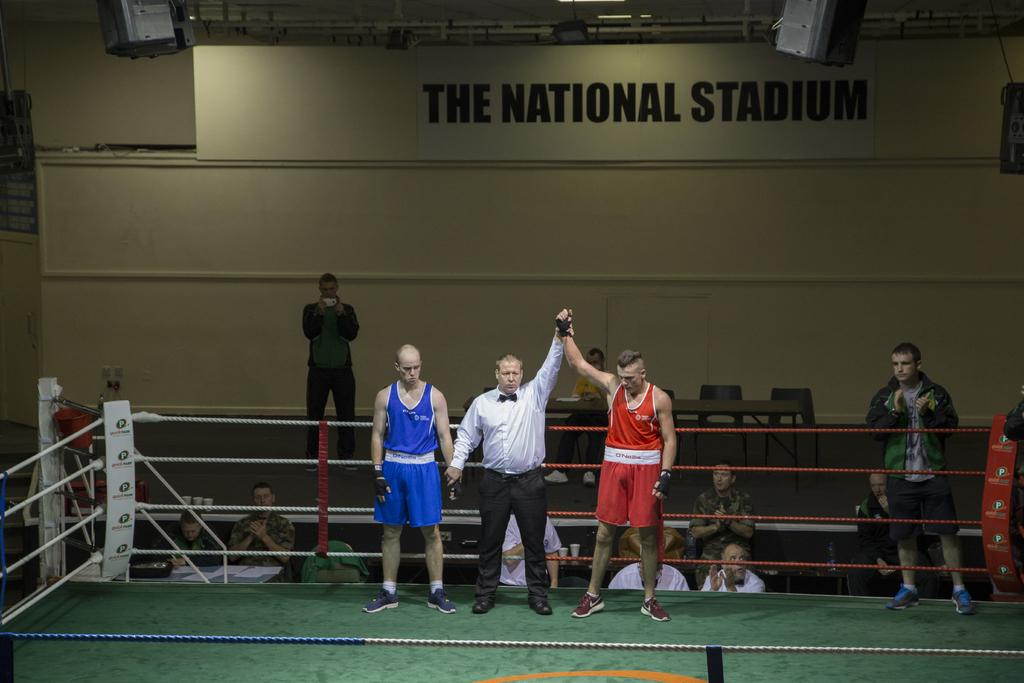<image>
Write a terse but informative summary of the picture. The National Stadium is hosting a boxing match, and the man in red just won. 